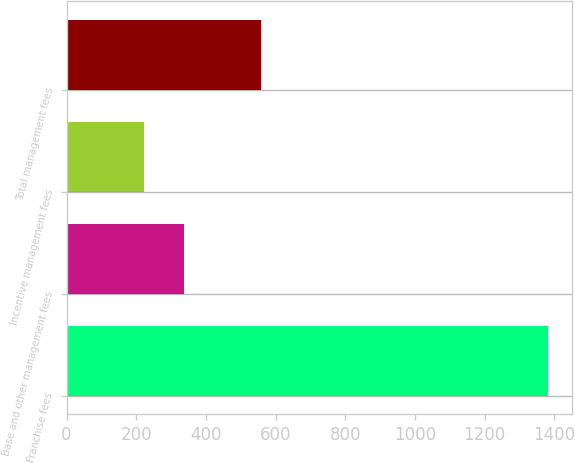<chart> <loc_0><loc_0><loc_500><loc_500><bar_chart><fcel>Franchise fees<fcel>Base and other management fees<fcel>Incentive management fees<fcel>Total management fees<nl><fcel>1382<fcel>338<fcel>222<fcel>558<nl></chart> 